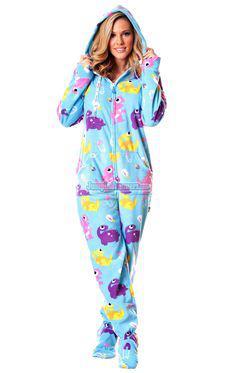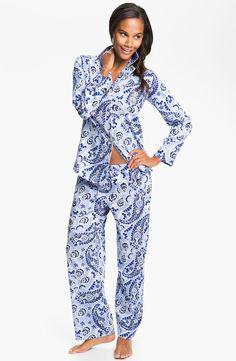The first image is the image on the left, the second image is the image on the right. For the images displayed, is the sentence "An image shows a brunette wearing printed blue pajamas." factually correct? Answer yes or no. Yes. The first image is the image on the left, the second image is the image on the right. Assess this claim about the two images: "The woman in the right image has one hand on her waist in posing position.". Correct or not? Answer yes or no. Yes. 